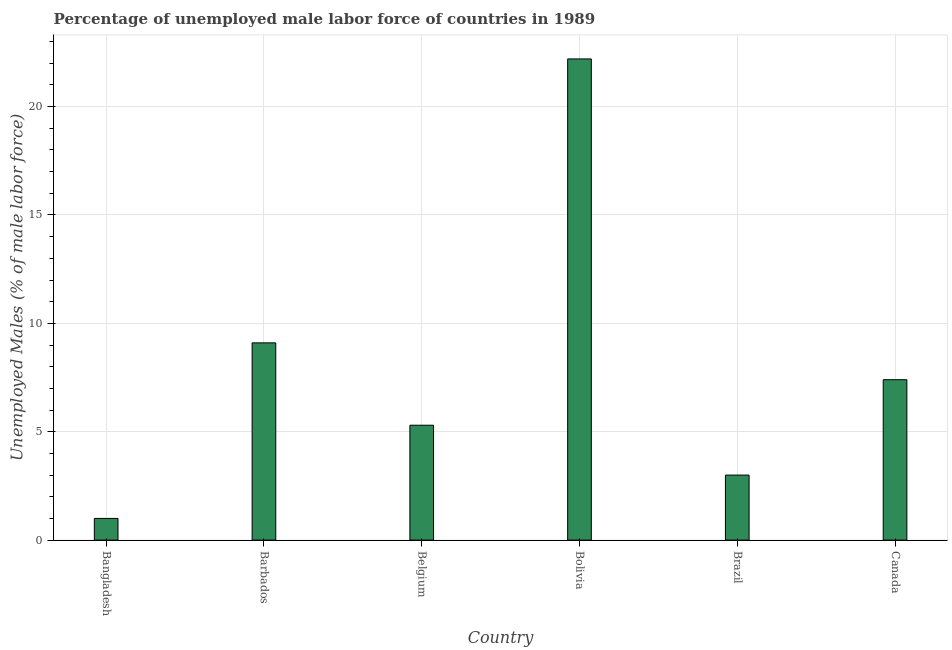Does the graph contain any zero values?
Make the answer very short. No. What is the title of the graph?
Your answer should be compact. Percentage of unemployed male labor force of countries in 1989. What is the label or title of the Y-axis?
Keep it short and to the point. Unemployed Males (% of male labor force). Across all countries, what is the maximum total unemployed male labour force?
Your answer should be compact. 22.2. Across all countries, what is the minimum total unemployed male labour force?
Keep it short and to the point. 1. What is the sum of the total unemployed male labour force?
Ensure brevity in your answer.  48. What is the difference between the total unemployed male labour force in Bangladesh and Bolivia?
Offer a very short reply. -21.2. What is the average total unemployed male labour force per country?
Provide a succinct answer. 8. What is the median total unemployed male labour force?
Your response must be concise. 6.35. What is the ratio of the total unemployed male labour force in Barbados to that in Bolivia?
Your response must be concise. 0.41. Is the total unemployed male labour force in Barbados less than that in Belgium?
Your answer should be very brief. No. What is the difference between the highest and the second highest total unemployed male labour force?
Provide a succinct answer. 13.1. Is the sum of the total unemployed male labour force in Belgium and Brazil greater than the maximum total unemployed male labour force across all countries?
Offer a very short reply. No. What is the difference between the highest and the lowest total unemployed male labour force?
Keep it short and to the point. 21.2. Are all the bars in the graph horizontal?
Offer a very short reply. No. What is the difference between two consecutive major ticks on the Y-axis?
Provide a succinct answer. 5. Are the values on the major ticks of Y-axis written in scientific E-notation?
Offer a very short reply. No. What is the Unemployed Males (% of male labor force) of Bangladesh?
Your response must be concise. 1. What is the Unemployed Males (% of male labor force) in Barbados?
Your answer should be compact. 9.1. What is the Unemployed Males (% of male labor force) of Belgium?
Keep it short and to the point. 5.3. What is the Unemployed Males (% of male labor force) in Bolivia?
Keep it short and to the point. 22.2. What is the Unemployed Males (% of male labor force) in Brazil?
Provide a succinct answer. 3. What is the Unemployed Males (% of male labor force) in Canada?
Provide a succinct answer. 7.4. What is the difference between the Unemployed Males (% of male labor force) in Bangladesh and Barbados?
Make the answer very short. -8.1. What is the difference between the Unemployed Males (% of male labor force) in Bangladesh and Bolivia?
Give a very brief answer. -21.2. What is the difference between the Unemployed Males (% of male labor force) in Bangladesh and Brazil?
Offer a terse response. -2. What is the difference between the Unemployed Males (% of male labor force) in Belgium and Bolivia?
Keep it short and to the point. -16.9. What is the difference between the Unemployed Males (% of male labor force) in Belgium and Brazil?
Your response must be concise. 2.3. What is the difference between the Unemployed Males (% of male labor force) in Belgium and Canada?
Your answer should be compact. -2.1. What is the difference between the Unemployed Males (% of male labor force) in Bolivia and Brazil?
Provide a succinct answer. 19.2. What is the difference between the Unemployed Males (% of male labor force) in Bolivia and Canada?
Your answer should be very brief. 14.8. What is the ratio of the Unemployed Males (% of male labor force) in Bangladesh to that in Barbados?
Your answer should be very brief. 0.11. What is the ratio of the Unemployed Males (% of male labor force) in Bangladesh to that in Belgium?
Your answer should be very brief. 0.19. What is the ratio of the Unemployed Males (% of male labor force) in Bangladesh to that in Bolivia?
Make the answer very short. 0.04. What is the ratio of the Unemployed Males (% of male labor force) in Bangladesh to that in Brazil?
Make the answer very short. 0.33. What is the ratio of the Unemployed Males (% of male labor force) in Bangladesh to that in Canada?
Offer a very short reply. 0.14. What is the ratio of the Unemployed Males (% of male labor force) in Barbados to that in Belgium?
Ensure brevity in your answer.  1.72. What is the ratio of the Unemployed Males (% of male labor force) in Barbados to that in Bolivia?
Offer a terse response. 0.41. What is the ratio of the Unemployed Males (% of male labor force) in Barbados to that in Brazil?
Give a very brief answer. 3.03. What is the ratio of the Unemployed Males (% of male labor force) in Barbados to that in Canada?
Make the answer very short. 1.23. What is the ratio of the Unemployed Males (% of male labor force) in Belgium to that in Bolivia?
Offer a very short reply. 0.24. What is the ratio of the Unemployed Males (% of male labor force) in Belgium to that in Brazil?
Offer a very short reply. 1.77. What is the ratio of the Unemployed Males (% of male labor force) in Belgium to that in Canada?
Offer a very short reply. 0.72. What is the ratio of the Unemployed Males (% of male labor force) in Brazil to that in Canada?
Keep it short and to the point. 0.41. 